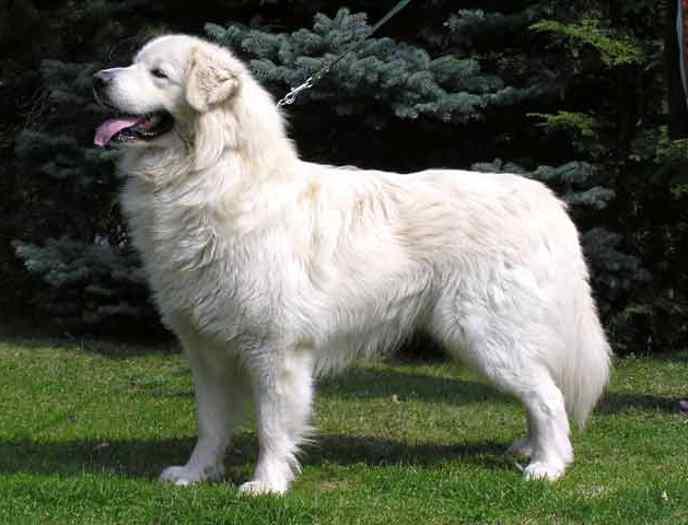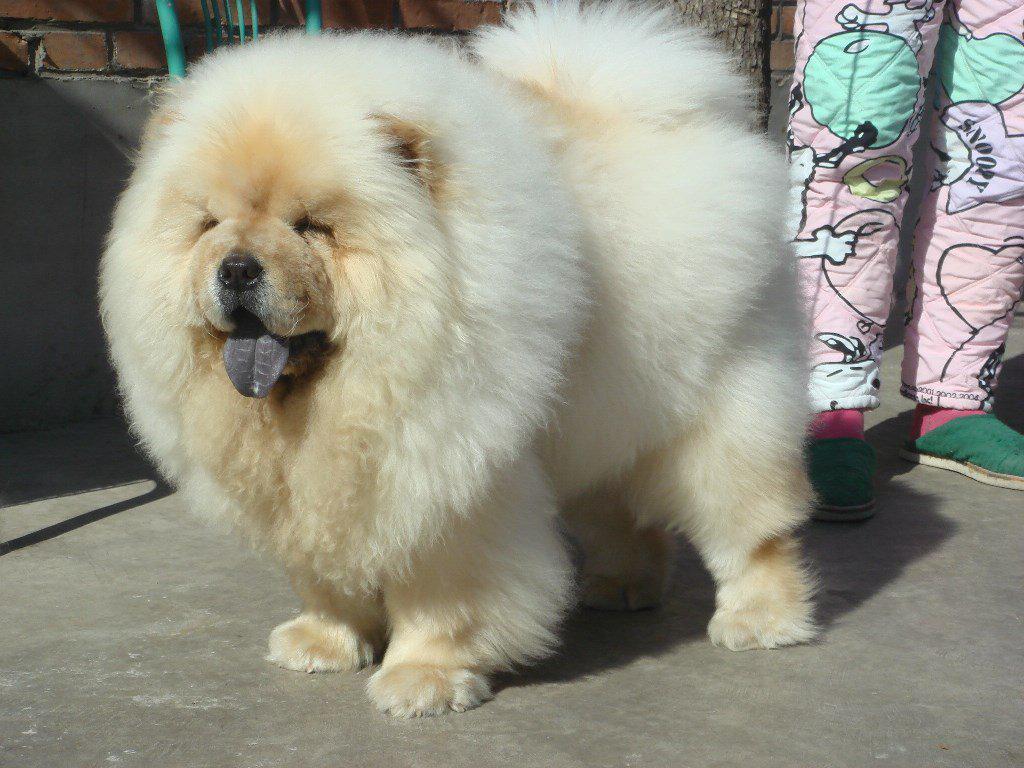The first image is the image on the left, the second image is the image on the right. Analyze the images presented: Is the assertion "At least one of the dogs has its tongue sticking out." valid? Answer yes or no. Yes. The first image is the image on the left, the second image is the image on the right. Assess this claim about the two images: "Dogs are sticking out their tongues far enough for the tongues to be visible.". Correct or not? Answer yes or no. Yes. 